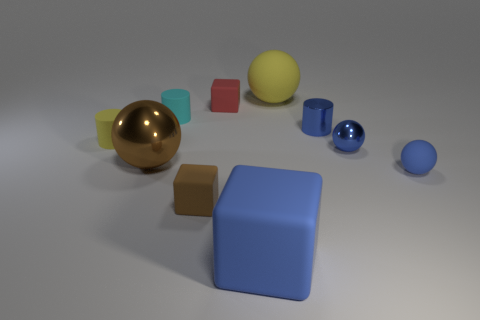What shape is the big matte object that is the same color as the small metallic ball?
Your answer should be compact. Cube. There is a tiny yellow thing that is the same material as the small red cube; what is its shape?
Your answer should be compact. Cylinder. There is a cylinder to the right of the big blue rubber block; is there a small yellow matte cylinder that is on the right side of it?
Make the answer very short. No. How big is the cyan matte object?
Make the answer very short. Small. How many objects are tiny brown metallic balls or tiny brown cubes?
Keep it short and to the point. 1. Is the material of the cylinder that is to the left of the cyan matte object the same as the big ball in front of the blue cylinder?
Your answer should be very brief. No. What is the color of the large thing that is the same material as the big yellow sphere?
Offer a terse response. Blue. What number of other spheres have the same size as the blue metal sphere?
Give a very brief answer. 1. How many other things are there of the same color as the metallic cylinder?
Your answer should be very brief. 3. There is a tiny blue object in front of the blue shiny ball; is its shape the same as the blue matte thing in front of the small blue matte object?
Your answer should be compact. No. 